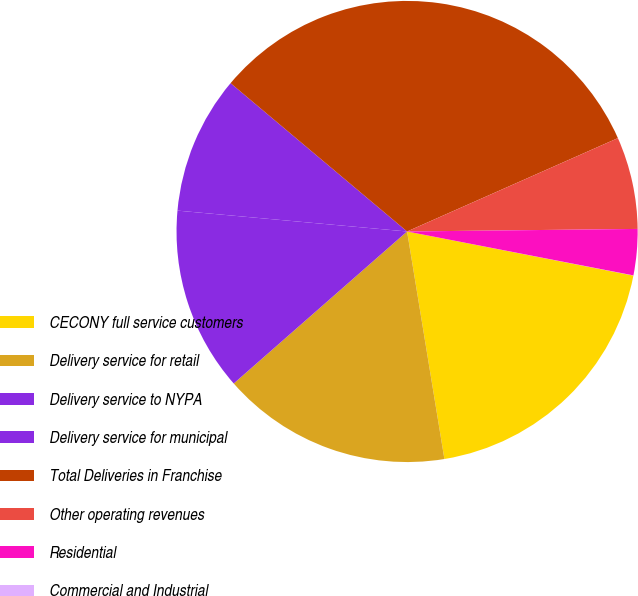Convert chart. <chart><loc_0><loc_0><loc_500><loc_500><pie_chart><fcel>CECONY full service customers<fcel>Delivery service for retail<fcel>Delivery service to NYPA<fcel>Delivery service for municipal<fcel>Total Deliveries in Franchise<fcel>Other operating revenues<fcel>Residential<fcel>Commercial and Industrial<nl><fcel>19.35%<fcel>16.13%<fcel>12.9%<fcel>9.68%<fcel>32.24%<fcel>6.46%<fcel>3.23%<fcel>0.01%<nl></chart> 